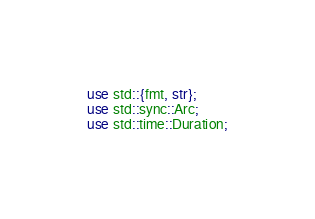Convert code to text. <code><loc_0><loc_0><loc_500><loc_500><_Rust_>use std::{fmt, str};
use std::sync::Arc;
use std::time::Duration;
</code> 